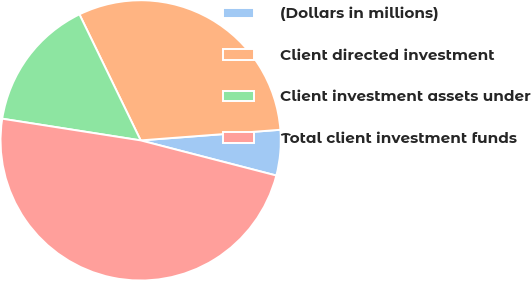Convert chart to OTSL. <chart><loc_0><loc_0><loc_500><loc_500><pie_chart><fcel>(Dollars in millions)<fcel>Client directed investment<fcel>Client investment assets under<fcel>Total client investment funds<nl><fcel>5.24%<fcel>30.99%<fcel>15.33%<fcel>48.44%<nl></chart> 